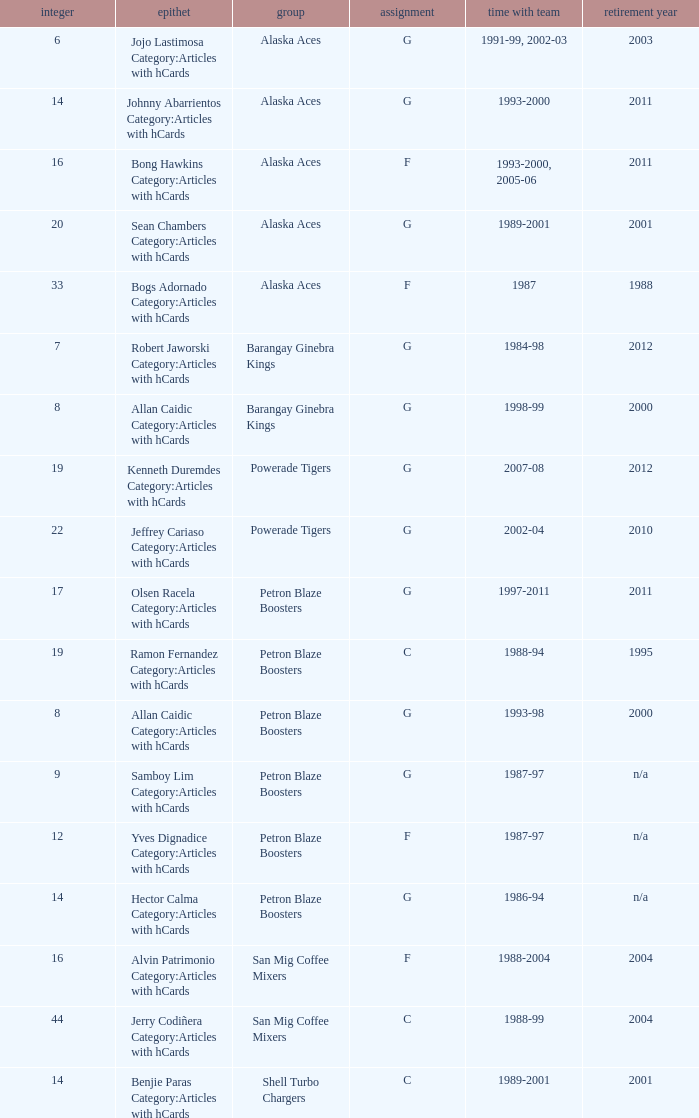Who was the player in Position G on the Petron Blaze Boosters and retired in 2000? Allan Caidic Category:Articles with hCards. 